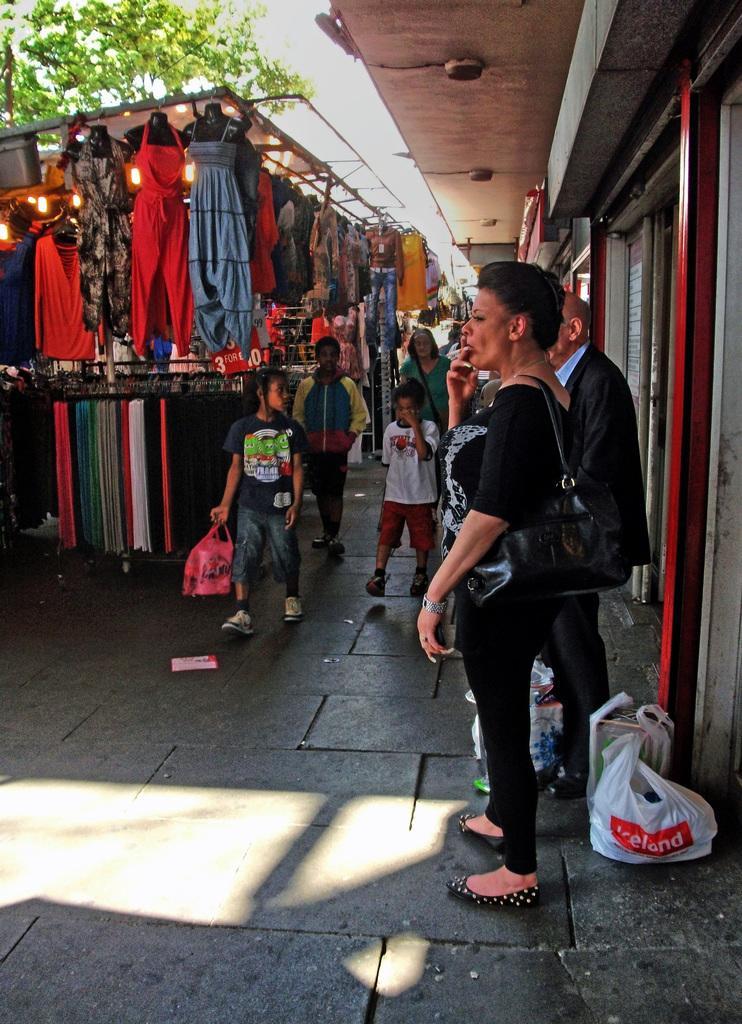Can you describe this image briefly? In this image I can see the group of people with different color dresses. I can see few people with the bags. I can see some bags on the road. To the right I can see the building. In-front of these people I can see many clothes and few clothes to the mannequins. In the background I can see the trees. 